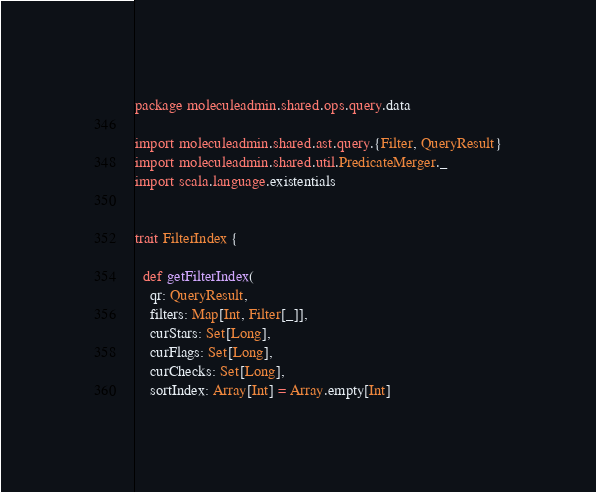Convert code to text. <code><loc_0><loc_0><loc_500><loc_500><_Scala_>package moleculeadmin.shared.ops.query.data

import moleculeadmin.shared.ast.query.{Filter, QueryResult}
import moleculeadmin.shared.util.PredicateMerger._
import scala.language.existentials


trait FilterIndex {

  def getFilterIndex(
    qr: QueryResult,
    filters: Map[Int, Filter[_]],
    curStars: Set[Long],
    curFlags: Set[Long],
    curChecks: Set[Long],
    sortIndex: Array[Int] = Array.empty[Int]</code> 